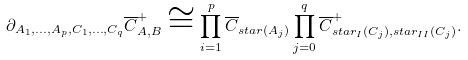<formula> <loc_0><loc_0><loc_500><loc_500>\partial _ { A _ { 1 } , \dots , A _ { p } , C _ { 1 } , \dots , C _ { q } } \overline { C } _ { A , B } ^ { + } \cong \prod _ { i = 1 } ^ { p } \overline { C } _ { s t a r ( A _ { j } ) } \prod _ { j = 0 } ^ { q } \overline { C } ^ { + } _ { s t a r _ { I } ( C _ { j } ) , s t a r _ { I I } ( C _ { j } ) } .</formula> 